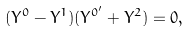<formula> <loc_0><loc_0><loc_500><loc_500>( Y ^ { 0 } - Y ^ { 1 } ) ( Y ^ { 0 ^ { \prime } } + Y ^ { 2 } ) = 0 ,</formula> 